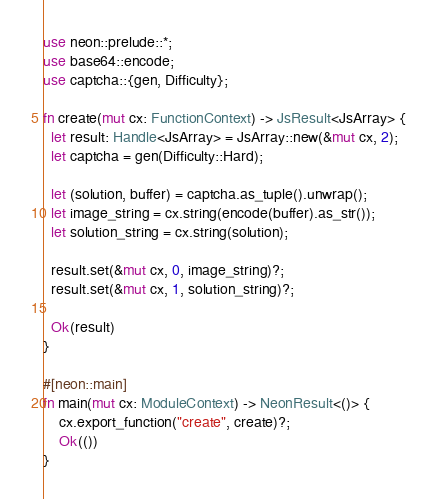Convert code to text. <code><loc_0><loc_0><loc_500><loc_500><_Rust_>use neon::prelude::*;
use base64::encode;
use captcha::{gen, Difficulty};

fn create(mut cx: FunctionContext) -> JsResult<JsArray> {
  let result: Handle<JsArray> = JsArray::new(&mut cx, 2);
  let captcha = gen(Difficulty::Hard);

  let (solution, buffer) = captcha.as_tuple().unwrap();
  let image_string = cx.string(encode(buffer).as_str());
  let solution_string = cx.string(solution);

  result.set(&mut cx, 0, image_string)?;
  result.set(&mut cx, 1, solution_string)?;

  Ok(result)
}

#[neon::main]
fn main(mut cx: ModuleContext) -> NeonResult<()> {
    cx.export_function("create", create)?;
    Ok(())
}
</code> 